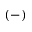<formula> <loc_0><loc_0><loc_500><loc_500>( - )</formula> 